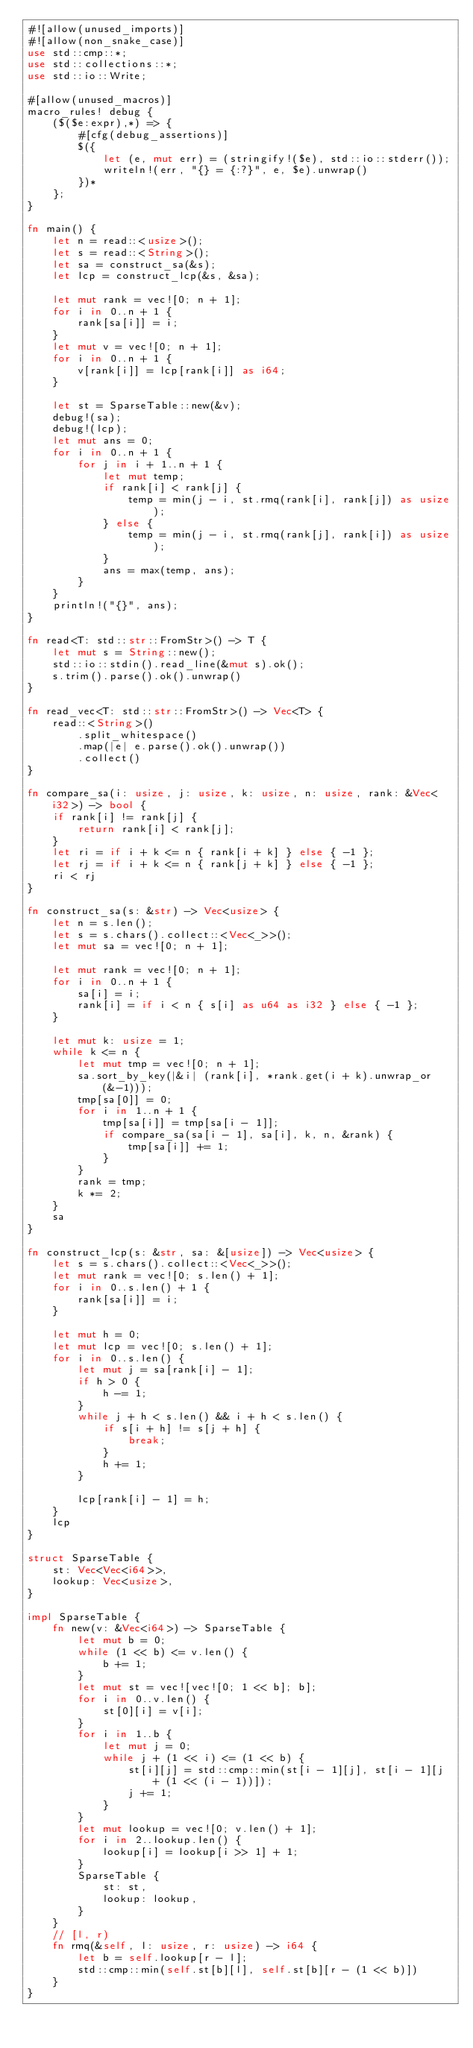<code> <loc_0><loc_0><loc_500><loc_500><_Rust_>#![allow(unused_imports)]
#![allow(non_snake_case)]
use std::cmp::*;
use std::collections::*;
use std::io::Write;

#[allow(unused_macros)]
macro_rules! debug {
    ($($e:expr),*) => {
        #[cfg(debug_assertions)]
        $({
            let (e, mut err) = (stringify!($e), std::io::stderr());
            writeln!(err, "{} = {:?}", e, $e).unwrap()
        })*
    };
}

fn main() {
    let n = read::<usize>();
    let s = read::<String>();
    let sa = construct_sa(&s);
    let lcp = construct_lcp(&s, &sa);

    let mut rank = vec![0; n + 1];
    for i in 0..n + 1 {
        rank[sa[i]] = i;
    }
    let mut v = vec![0; n + 1];
    for i in 0..n + 1 {
        v[rank[i]] = lcp[rank[i]] as i64;
    }

    let st = SparseTable::new(&v);
    debug!(sa);
    debug!(lcp);
    let mut ans = 0;
    for i in 0..n + 1 {
        for j in i + 1..n + 1 {
            let mut temp;
            if rank[i] < rank[j] {
                temp = min(j - i, st.rmq(rank[i], rank[j]) as usize);
            } else {
                temp = min(j - i, st.rmq(rank[j], rank[i]) as usize);
            }
            ans = max(temp, ans);
        }
    }
    println!("{}", ans);
}

fn read<T: std::str::FromStr>() -> T {
    let mut s = String::new();
    std::io::stdin().read_line(&mut s).ok();
    s.trim().parse().ok().unwrap()
}

fn read_vec<T: std::str::FromStr>() -> Vec<T> {
    read::<String>()
        .split_whitespace()
        .map(|e| e.parse().ok().unwrap())
        .collect()
}

fn compare_sa(i: usize, j: usize, k: usize, n: usize, rank: &Vec<i32>) -> bool {
    if rank[i] != rank[j] {
        return rank[i] < rank[j];
    }
    let ri = if i + k <= n { rank[i + k] } else { -1 };
    let rj = if i + k <= n { rank[j + k] } else { -1 };
    ri < rj
}

fn construct_sa(s: &str) -> Vec<usize> {
    let n = s.len();
    let s = s.chars().collect::<Vec<_>>();
    let mut sa = vec![0; n + 1];

    let mut rank = vec![0; n + 1];
    for i in 0..n + 1 {
        sa[i] = i;
        rank[i] = if i < n { s[i] as u64 as i32 } else { -1 };
    }

    let mut k: usize = 1;
    while k <= n {
        let mut tmp = vec![0; n + 1];
        sa.sort_by_key(|&i| (rank[i], *rank.get(i + k).unwrap_or(&-1)));
        tmp[sa[0]] = 0;
        for i in 1..n + 1 {
            tmp[sa[i]] = tmp[sa[i - 1]];
            if compare_sa(sa[i - 1], sa[i], k, n, &rank) {
                tmp[sa[i]] += 1;
            }
        }
        rank = tmp;
        k *= 2;
    }
    sa
}

fn construct_lcp(s: &str, sa: &[usize]) -> Vec<usize> {
    let s = s.chars().collect::<Vec<_>>();
    let mut rank = vec![0; s.len() + 1];
    for i in 0..s.len() + 1 {
        rank[sa[i]] = i;
    }

    let mut h = 0;
    let mut lcp = vec![0; s.len() + 1];
    for i in 0..s.len() {
        let mut j = sa[rank[i] - 1];
        if h > 0 {
            h -= 1;
        }
        while j + h < s.len() && i + h < s.len() {
            if s[i + h] != s[j + h] {
                break;
            }
            h += 1;
        }

        lcp[rank[i] - 1] = h;
    }
    lcp
}

struct SparseTable {
    st: Vec<Vec<i64>>,
    lookup: Vec<usize>,
}

impl SparseTable {
    fn new(v: &Vec<i64>) -> SparseTable {
        let mut b = 0;
        while (1 << b) <= v.len() {
            b += 1;
        }
        let mut st = vec![vec![0; 1 << b]; b];
        for i in 0..v.len() {
            st[0][i] = v[i];
        }
        for i in 1..b {
            let mut j = 0;
            while j + (1 << i) <= (1 << b) {
                st[i][j] = std::cmp::min(st[i - 1][j], st[i - 1][j + (1 << (i - 1))]);
                j += 1;
            }
        }
        let mut lookup = vec![0; v.len() + 1];
        for i in 2..lookup.len() {
            lookup[i] = lookup[i >> 1] + 1;
        }
        SparseTable {
            st: st,
            lookup: lookup,
        }
    }
    // [l, r)
    fn rmq(&self, l: usize, r: usize) -> i64 {
        let b = self.lookup[r - l];
        std::cmp::min(self.st[b][l], self.st[b][r - (1 << b)])
    }
}
</code> 